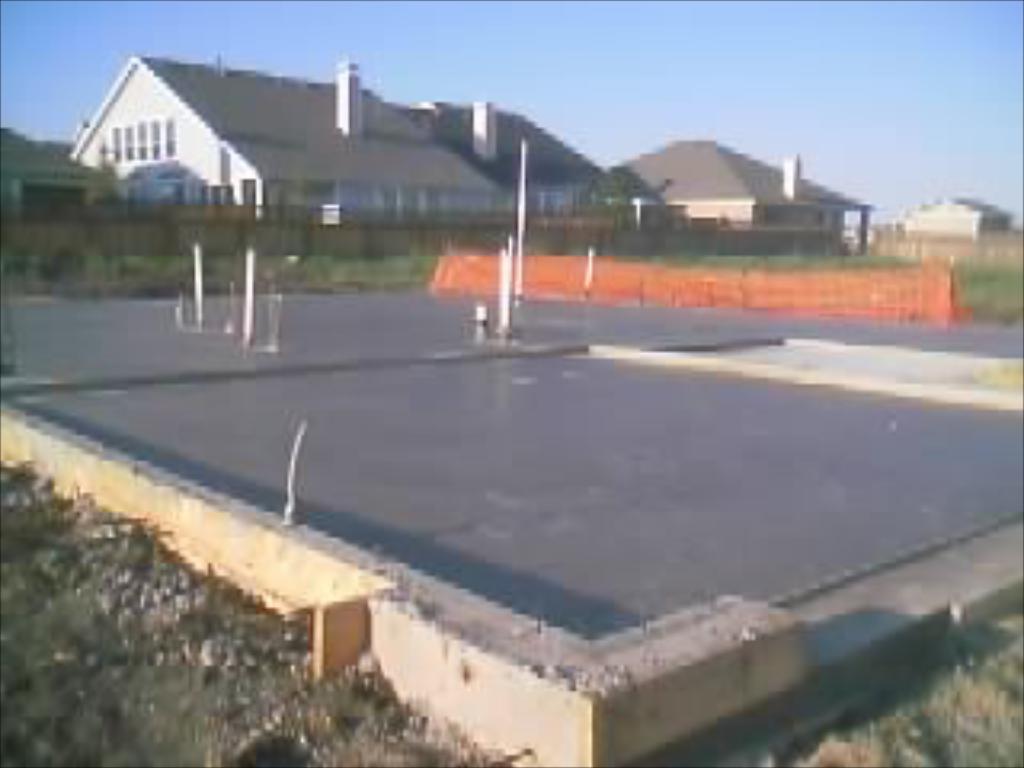Could you give a brief overview of what you see in this image? In this image there is a car parking place, behind the car parking place there are houses. 